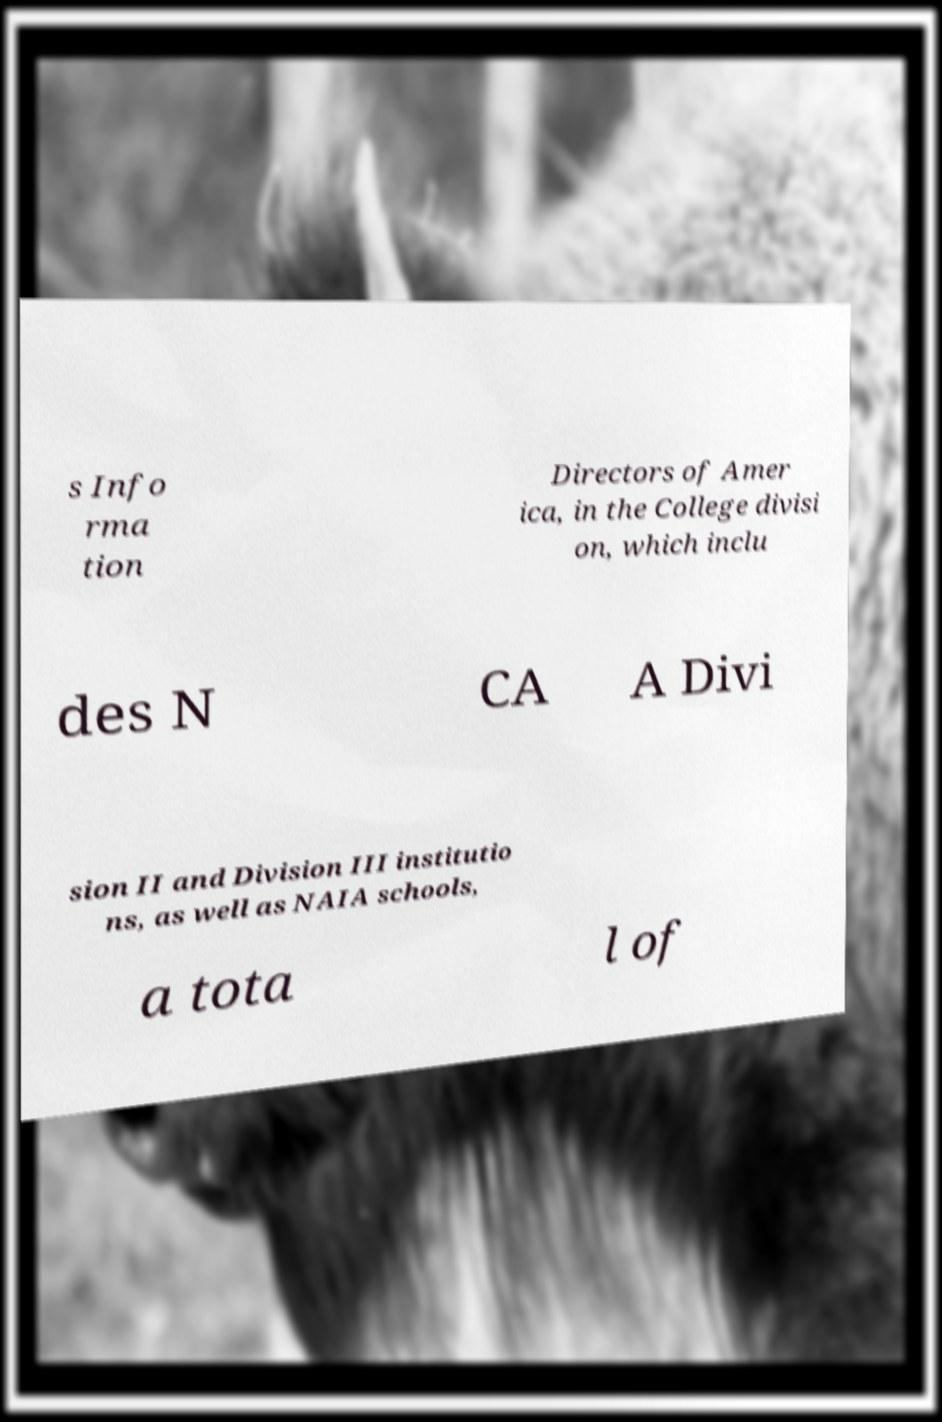What messages or text are displayed in this image? I need them in a readable, typed format. s Info rma tion Directors of Amer ica, in the College divisi on, which inclu des N CA A Divi sion II and Division III institutio ns, as well as NAIA schools, a tota l of 